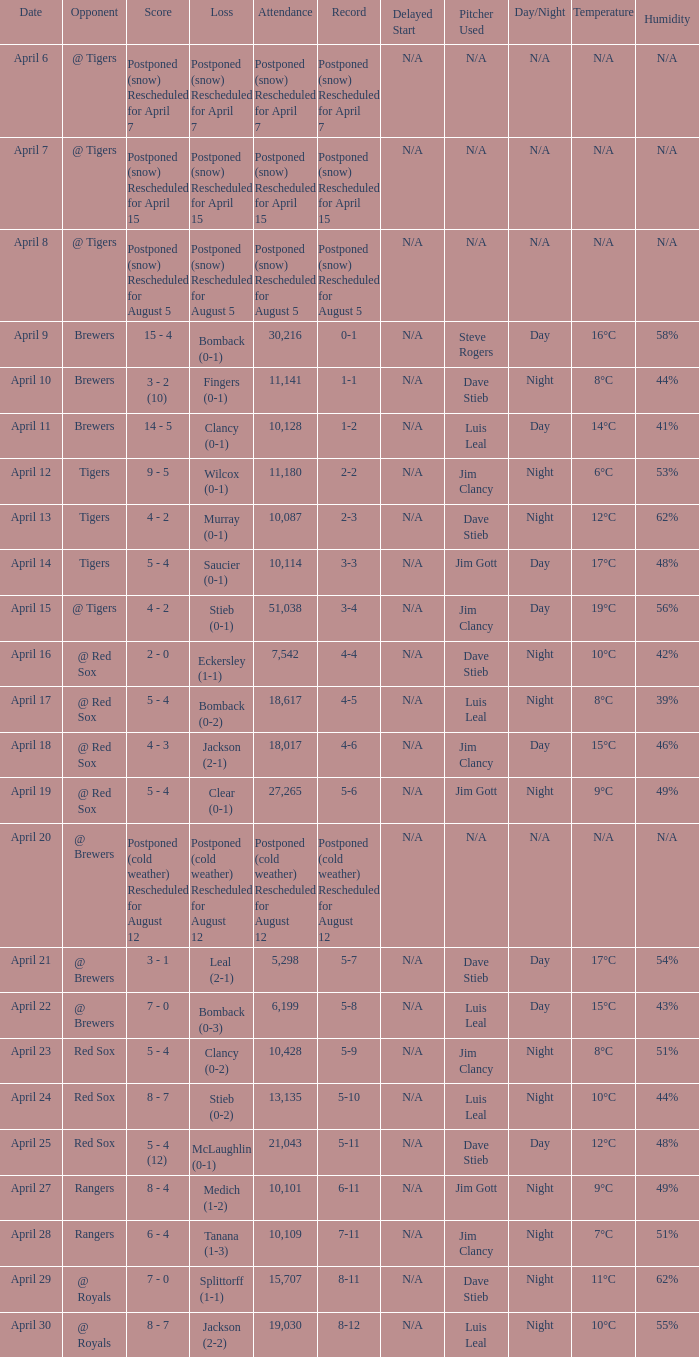What was the date for the game that had an attendance of 10,101? April 27. 